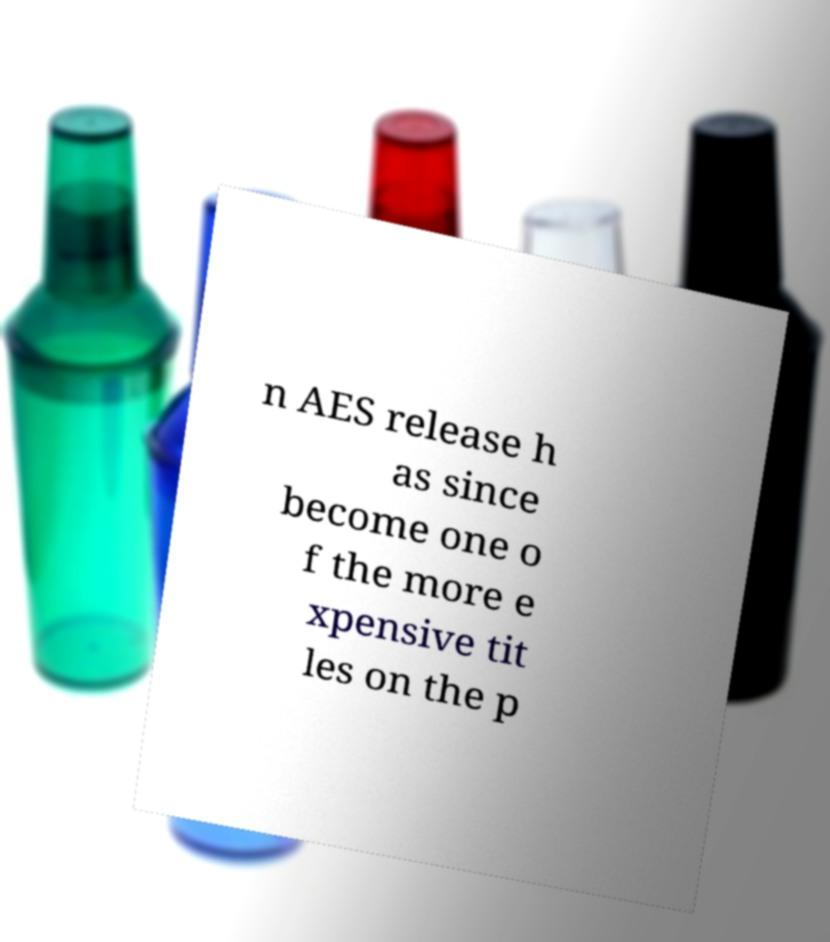Can you read and provide the text displayed in the image?This photo seems to have some interesting text. Can you extract and type it out for me? n AES release h as since become one o f the more e xpensive tit les on the p 